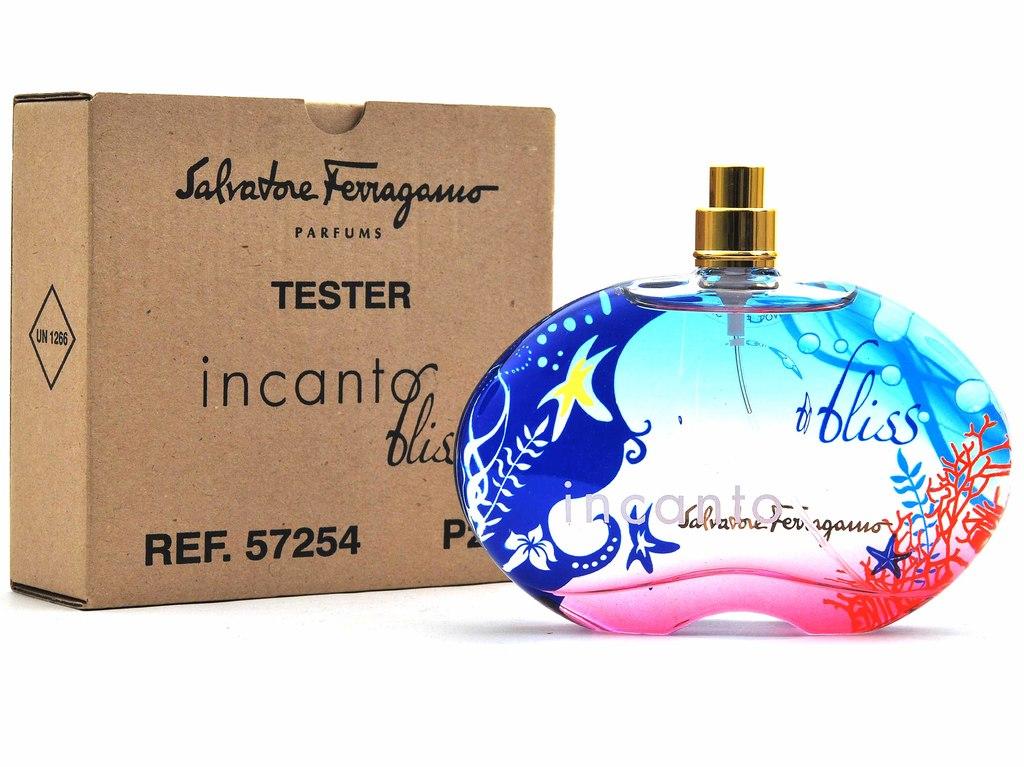What is the name of the perfume?
Your answer should be very brief. Bliss. Who makes this perfume?
Provide a short and direct response. Salvatore ferragamo. 